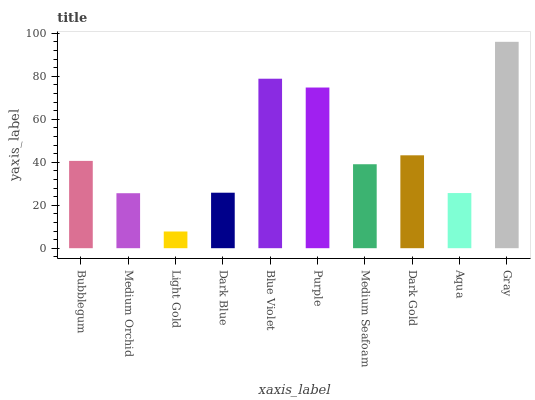Is Light Gold the minimum?
Answer yes or no. Yes. Is Gray the maximum?
Answer yes or no. Yes. Is Medium Orchid the minimum?
Answer yes or no. No. Is Medium Orchid the maximum?
Answer yes or no. No. Is Bubblegum greater than Medium Orchid?
Answer yes or no. Yes. Is Medium Orchid less than Bubblegum?
Answer yes or no. Yes. Is Medium Orchid greater than Bubblegum?
Answer yes or no. No. Is Bubblegum less than Medium Orchid?
Answer yes or no. No. Is Bubblegum the high median?
Answer yes or no. Yes. Is Medium Seafoam the low median?
Answer yes or no. Yes. Is Aqua the high median?
Answer yes or no. No. Is Purple the low median?
Answer yes or no. No. 